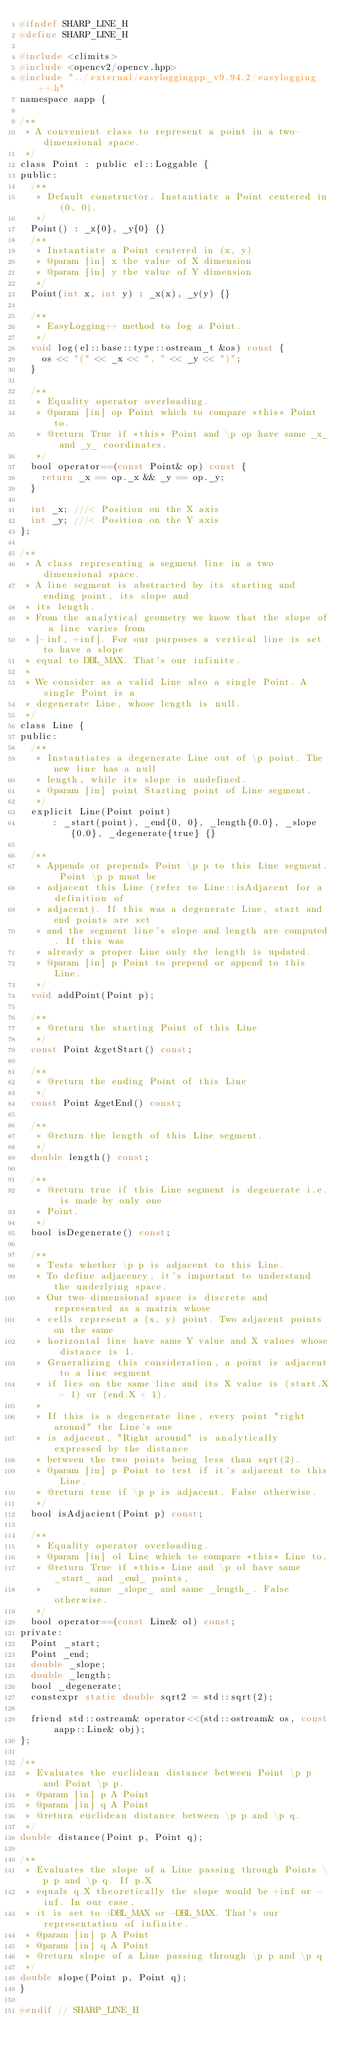<code> <loc_0><loc_0><loc_500><loc_500><_C_>#ifndef SHARP_LINE_H
#define SHARP_LINE_H

#include <climits>
#include <opencv2/opencv.hpp>
#include "../external/easyloggingpp_v9.94.2/easylogging++.h"
namespace aapp {

/**
 * A convenient class to represent a point in a two-dimensional space.
 */
class Point : public el::Loggable {
public:
  /**
   * Default constructor. Instantiate a Point centered in (0, 0).
   */
  Point() : _x{0}, _y{0} {}
  /**
   * Instantiate a Point centered in (x, y)
   * @param [in] x the value of X dimension
   * @param [in] y the value of Y dimension
   */
  Point(int x, int y) : _x(x), _y(y) {}

  /**
   * EasyLogging++ method to log a Point.
   */
  void log(el::base::type::ostream_t &os) const {
    os << "(" << _x << ", " << _y << ")";
  }

  /**
   * Equality operator overloading.
   * @param [in] op Point which to compare *this* Point to.
   * @return True if *this* Point and \p op have same _x_ and _y_ coordinates.
   */
  bool operator==(const Point& op) const {
    return _x == op._x && _y == op._y;
  }

  int _x; ///< Position on the X axis
  int _y; ///< Position on the Y axis
};

/**
 * A class representing a segment line in a two dimensional space.
 * A line segment is abstracted by its starting and ending point, its slope and
 * its length.
 * From the analytical geometry we know that the slope of a line varies from
 * [-inf, +inf]. For our purposes a vertical line is set to have a slope
 * equal to DBL_MAX. That's our infinite.
 *
 * We consider as a valid Line also a single Point. A single Point is a
 * degenerate Line, whose length is null.
 */
class Line {
public:
  /**
   * Instantiates a degenerate Line out of \p point. The new line has a null
   * length, while its slope is undefined.
   * @param [in] point Starting point of Line segment.
   */
  explicit Line(Point point)
      : _start(point), _end{0, 0}, _length{0.0}, _slope{0.0}, _degenerate{true} {}

  /**
   * Appends or prepends Point \p p to this Line segment. Point \p p must be
   * adjacent this Line (refer to Line::isAdjacent for a definition of
   * adjacent). If this was a degenerate Line, start and end points are set
   * and the segment line's slope and length are computed. If this was
   * already a proper Line only the length is updated.
   * @param [in] p Point to prepend or append to this Line.
   */
  void addPoint(Point p);

  /**
   * @return the starting Point of this Line
   */
  const Point &getStart() const;

  /**
   * @return the ending Point of this Line
   */
  const Point &getEnd() const;

  /**
   * @return the length of this Line segment.
   */
  double length() const;

  /**
   * @return true if this Line segment is degenerate i.e. is made by only one
   * Point.
   */
  bool isDegenerate() const;

  /**
   * Tests whether \p p is adjacent to this Line.
   * To define adjacency, it's important to understand the underlying space.
   * Our two-dimensional space is discrete and represented as a matrix whose
   * cells represent a (x, y) point. Two adjacent points on the same
   * horizontal line have same Y value and X values whose distance is 1.
   * Generalizing this consideration, a point is adjacent to a line segment
   * if lies on the same line and its X value is (start.X - 1) or (end.X + 1).
   *
   * If this is a degenerate line, every point "right around" the Line's one
   * is adjacent. "Right around" is analytically expressed by the distance
   * between the two points being less than sqrt(2).
   * @param [in] p Point to test if it's adjacent to this Line.
   * @return true if \p p is adjacent. False otherwise.
   */
  bool isAdjacient(Point p) const;

  /**
   * Equality operator overloading.
   * @param [in] ol Line which to compare *this* Line to.
   * @return True if *this* Line and \p ol have same _start_ and _end_ points,
   *         same _slope_ and same _length_. False otherwise.
   */
  bool operator==(const Line& ol) const;
private:
  Point _start;
  Point _end;
  double _slope;
  double _length;
  bool _degenerate;
  constexpr static double sqrt2 = std::sqrt(2);

  friend std::ostream& operator<<(std::ostream& os, const aapp::Line& obj);
};

/**
 * Evaluates the euclidean distance between Point \p p and Point \p p.
 * @param [in] p A Point
 * @param [in] q A Point
 * @return euclidean distance between \p p and \p q.
 */
double distance(Point p, Point q);

/**
 * Evaluates the slope of a Line passing through Points \p p and \p q. If p.X
 * equals q.X theoretically the slope would be +inf or -inf. In our case,
 * it is set to +DBL_MAX or -DBL_MAX. That's our representation of infinite.
 * @param [in] p A Point
 * @param [in] q A Point
 * @return slope of a Line passing through \p p and \p q
 */
double slope(Point p, Point q);
}

#endif // SHARP_LINE_H
</code> 